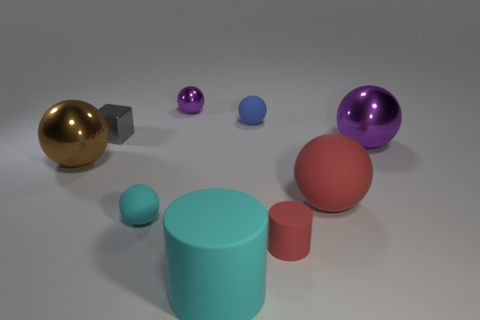Subtract all tiny cyan rubber balls. How many balls are left? 5 Subtract all brown cylinders. How many purple balls are left? 2 Subtract all red cylinders. How many cylinders are left? 1 Subtract all purple cylinders. Subtract all cyan cubes. How many cylinders are left? 2 Subtract all big purple metallic balls. Subtract all small metal things. How many objects are left? 6 Add 5 small rubber cylinders. How many small rubber cylinders are left? 6 Add 2 big metal spheres. How many big metal spheres exist? 4 Subtract 1 brown balls. How many objects are left? 8 Subtract all blocks. How many objects are left? 8 Subtract 2 cylinders. How many cylinders are left? 0 